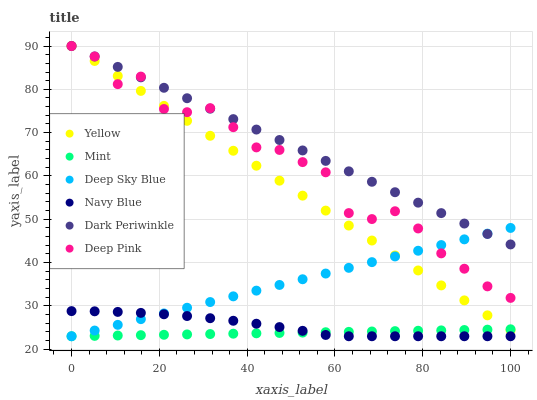Does Mint have the minimum area under the curve?
Answer yes or no. Yes. Does Dark Periwinkle have the maximum area under the curve?
Answer yes or no. Yes. Does Navy Blue have the minimum area under the curve?
Answer yes or no. No. Does Navy Blue have the maximum area under the curve?
Answer yes or no. No. Is Deep Sky Blue the smoothest?
Answer yes or no. Yes. Is Deep Pink the roughest?
Answer yes or no. Yes. Is Navy Blue the smoothest?
Answer yes or no. No. Is Navy Blue the roughest?
Answer yes or no. No. Does Navy Blue have the lowest value?
Answer yes or no. Yes. Does Yellow have the lowest value?
Answer yes or no. No. Does Dark Periwinkle have the highest value?
Answer yes or no. Yes. Does Navy Blue have the highest value?
Answer yes or no. No. Is Navy Blue less than Deep Pink?
Answer yes or no. Yes. Is Deep Pink greater than Mint?
Answer yes or no. Yes. Does Deep Sky Blue intersect Mint?
Answer yes or no. Yes. Is Deep Sky Blue less than Mint?
Answer yes or no. No. Is Deep Sky Blue greater than Mint?
Answer yes or no. No. Does Navy Blue intersect Deep Pink?
Answer yes or no. No. 